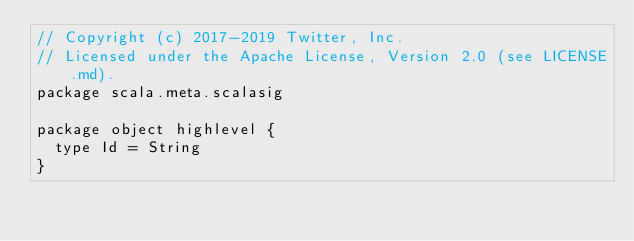Convert code to text. <code><loc_0><loc_0><loc_500><loc_500><_Scala_>// Copyright (c) 2017-2019 Twitter, Inc.
// Licensed under the Apache License, Version 2.0 (see LICENSE.md).
package scala.meta.scalasig

package object highlevel {
  type Id = String
}
</code> 